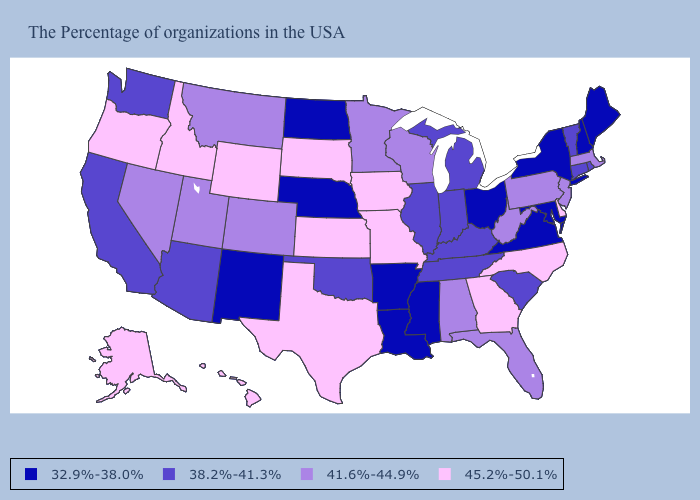What is the value of Louisiana?
Give a very brief answer. 32.9%-38.0%. Does New York have the lowest value in the USA?
Be succinct. Yes. What is the value of Delaware?
Give a very brief answer. 45.2%-50.1%. What is the highest value in states that border Louisiana?
Be succinct. 45.2%-50.1%. Name the states that have a value in the range 38.2%-41.3%?
Short answer required. Rhode Island, Vermont, Connecticut, South Carolina, Michigan, Kentucky, Indiana, Tennessee, Illinois, Oklahoma, Arizona, California, Washington. What is the value of New York?
Write a very short answer. 32.9%-38.0%. What is the value of Minnesota?
Quick response, please. 41.6%-44.9%. Name the states that have a value in the range 38.2%-41.3%?
Short answer required. Rhode Island, Vermont, Connecticut, South Carolina, Michigan, Kentucky, Indiana, Tennessee, Illinois, Oklahoma, Arizona, California, Washington. What is the value of Mississippi?
Answer briefly. 32.9%-38.0%. Does Vermont have the same value as Michigan?
Answer briefly. Yes. Does the map have missing data?
Write a very short answer. No. Does South Dakota have the lowest value in the USA?
Be succinct. No. Which states hav the highest value in the West?
Concise answer only. Wyoming, Idaho, Oregon, Alaska, Hawaii. Does Minnesota have the lowest value in the USA?
Answer briefly. No. Name the states that have a value in the range 41.6%-44.9%?
Short answer required. Massachusetts, New Jersey, Pennsylvania, West Virginia, Florida, Alabama, Wisconsin, Minnesota, Colorado, Utah, Montana, Nevada. 